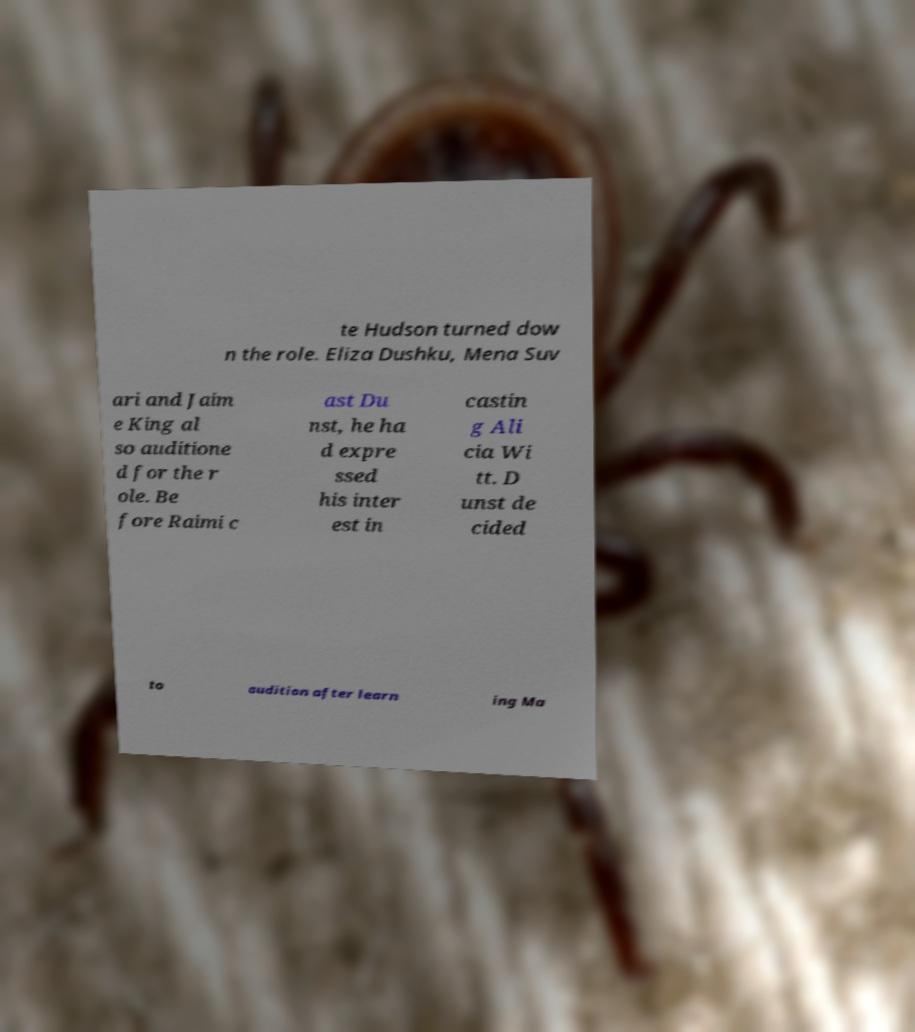What messages or text are displayed in this image? I need them in a readable, typed format. te Hudson turned dow n the role. Eliza Dushku, Mena Suv ari and Jaim e King al so auditione d for the r ole. Be fore Raimi c ast Du nst, he ha d expre ssed his inter est in castin g Ali cia Wi tt. D unst de cided to audition after learn ing Ma 